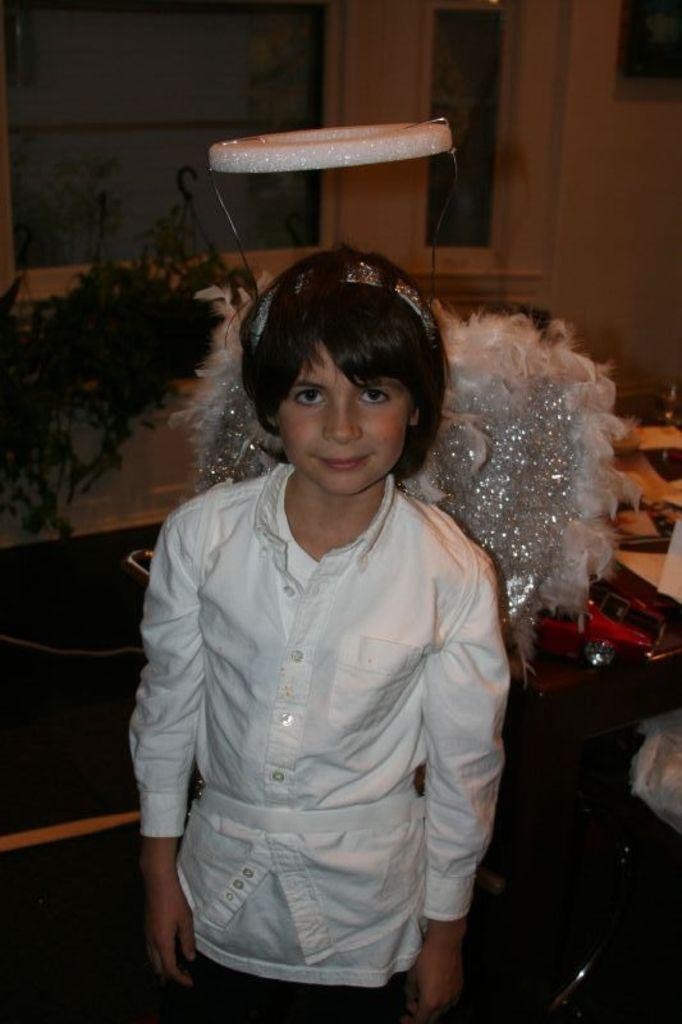What is the main subject of the image? There is a girl in the image. What is the girl doing in the image? The girl is smiling. What can be seen in the background of the image? There is a plant and a toy in the background of the image. What type of tank is visible in the image? There is no tank present in the image. What color is the girl's skin in the image? The color of the girl's skin is not mentioned in the provided facts, and therefore cannot be determined from the image. 